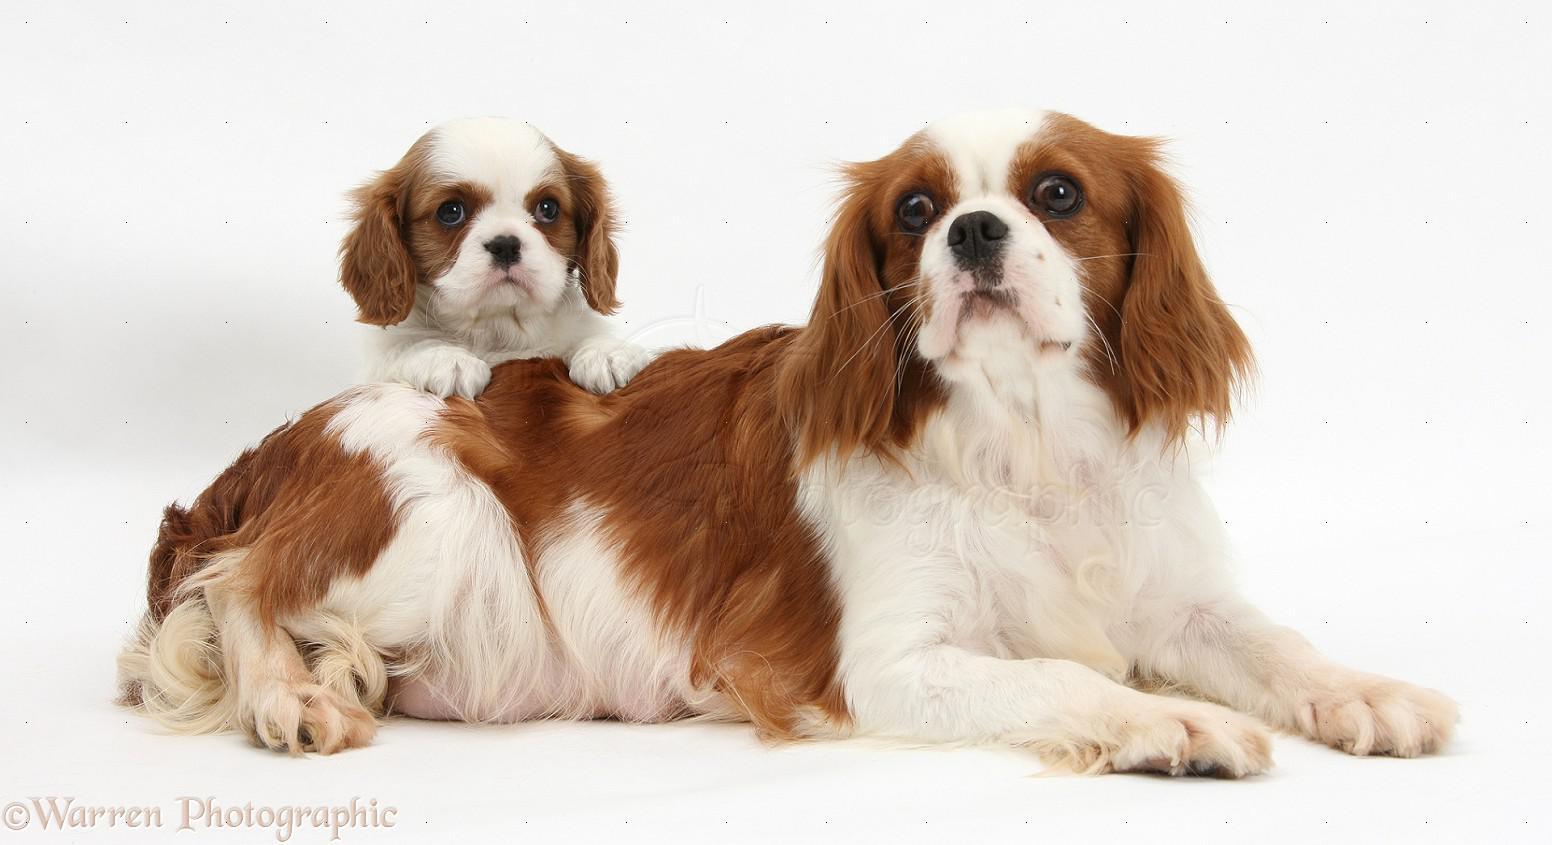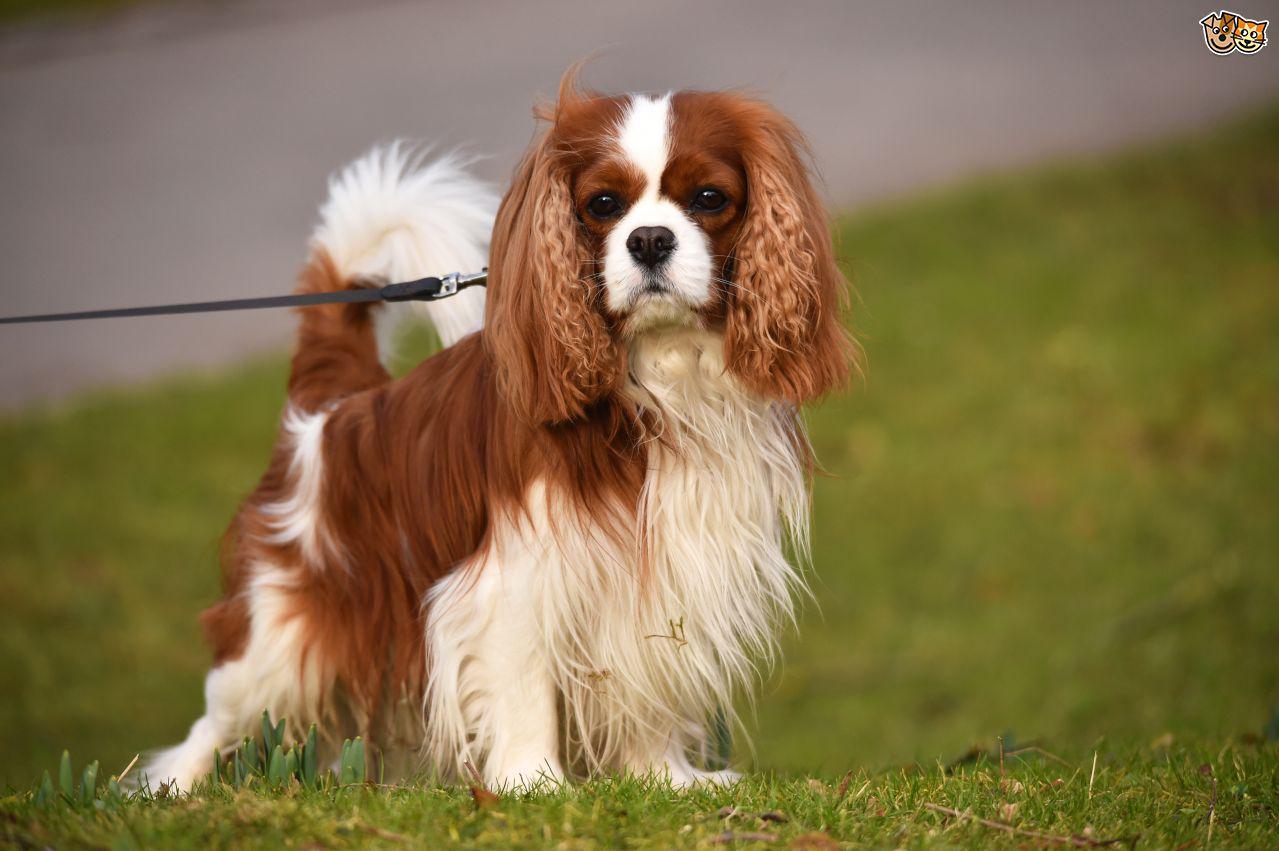The first image is the image on the left, the second image is the image on the right. Assess this claim about the two images: "One of the images contains a dog that is standing.". Correct or not? Answer yes or no. Yes. 